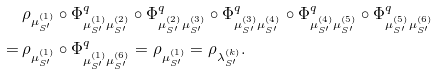Convert formula to latex. <formula><loc_0><loc_0><loc_500><loc_500>& \rho _ { \mu ^ { ( 1 ) } _ { S ^ { \prime } } } \circ \Phi _ { \mu ^ { ( 1 ) } _ { S ^ { \prime } } \mu ^ { ( 2 ) } _ { S ^ { \prime } } } ^ { q } \circ \Phi _ { \mu ^ { ( 2 ) } _ { S ^ { \prime } } \mu ^ { ( 3 ) } _ { S ^ { \prime } } } ^ { q } \circ \Phi _ { \mu ^ { ( 3 ) } _ { S ^ { \prime } } \mu ^ { ( 4 ) } _ { S ^ { \prime } } } ^ { q } \circ \Phi _ { \mu ^ { ( 4 ) } _ { S ^ { \prime } } \mu ^ { ( 5 ) } _ { S ^ { \prime } } } ^ { q } \circ \Phi _ { \mu ^ { ( 5 ) } _ { S ^ { \prime } } \mu ^ { ( 6 ) } _ { S ^ { \prime } } } ^ { q } \\ = \, & \rho _ { \mu ^ { ( 1 ) } _ { S ^ { \prime } } } \circ \Phi _ { \mu ^ { ( 1 ) } _ { S ^ { \prime } } \mu ^ { ( 6 ) } _ { S ^ { \prime } } } ^ { q } = \rho _ { \mu ^ { ( 1 ) } _ { S ^ { \prime } } } = \rho _ { \lambda ^ { ( k ) } _ { S ^ { \prime } } } .</formula> 